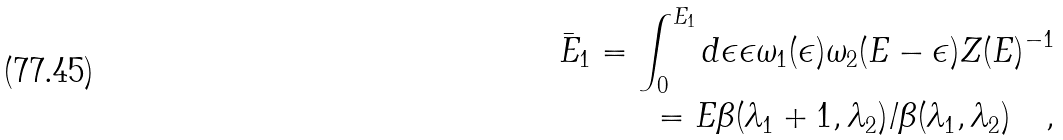Convert formula to latex. <formula><loc_0><loc_0><loc_500><loc_500>\bar { E } _ { 1 } = \int _ { 0 } ^ { E _ { 1 } } d \epsilon \epsilon \omega _ { 1 } ( \epsilon ) \omega _ { 2 } ( E - \epsilon ) Z ( E ) ^ { - 1 } \\ = E \beta ( \lambda _ { 1 } + 1 , \lambda _ { 2 } ) / \beta ( \lambda _ { 1 } , \lambda _ { 2 } ) \quad ,</formula> 